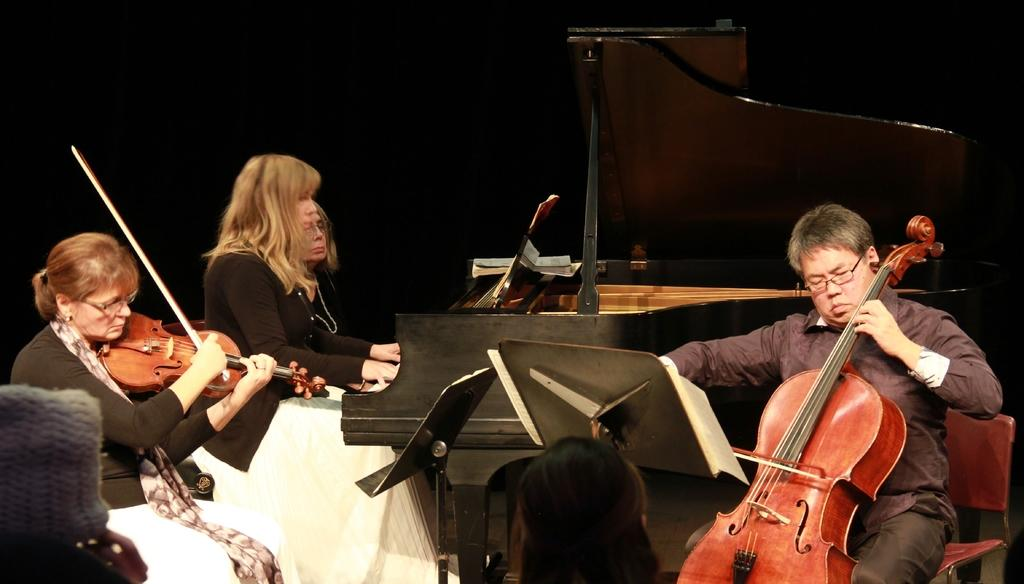How many people are in the image? There are people in the image. Can you describe the gender of the people in the image? Three of the people are women, and one is a man. What are the people in the image doing? All of the people are holding musical instruments. What type of glue is being used by the man in the image? There is no glue present in the image; the people are holding musical instruments. 